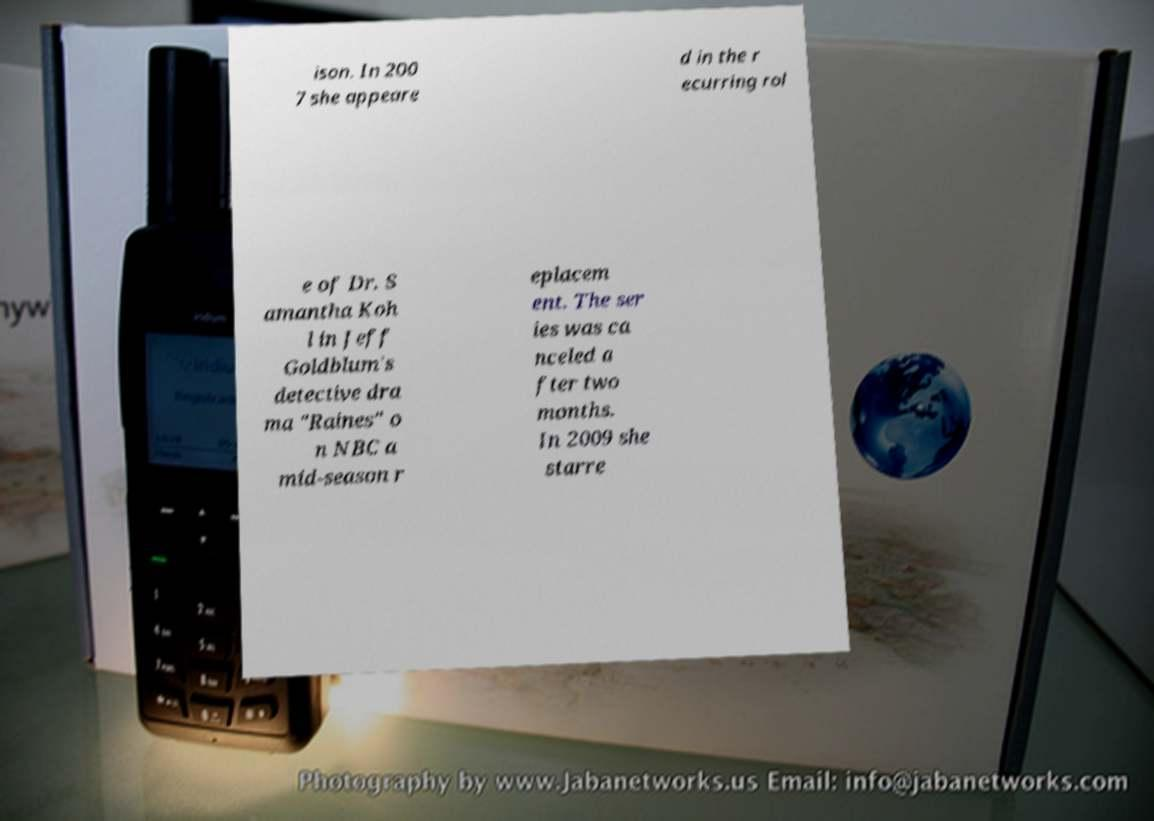Please read and relay the text visible in this image. What does it say? ison. In 200 7 she appeare d in the r ecurring rol e of Dr. S amantha Koh l in Jeff Goldblum's detective dra ma "Raines" o n NBC a mid-season r eplacem ent. The ser ies was ca nceled a fter two months. In 2009 she starre 